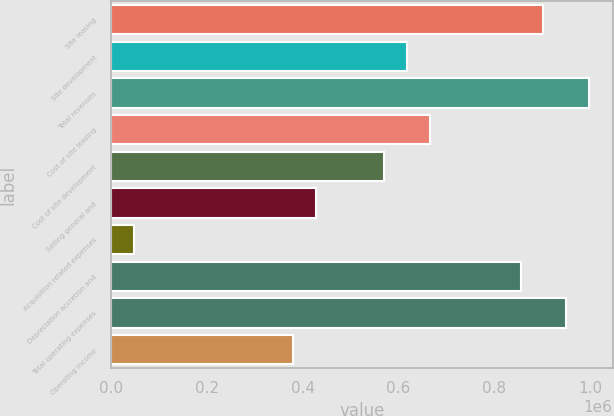Convert chart to OTSL. <chart><loc_0><loc_0><loc_500><loc_500><bar_chart><fcel>Site leasing<fcel>Site development<fcel>Total revenues<fcel>Cost of site leasing<fcel>Cost of site development<fcel>Selling general and<fcel>Acquisition related expenses<fcel>Depreciation accretion and<fcel>Total operating expenses<fcel>Operating income<nl><fcel>902412<fcel>617440<fcel>997403<fcel>664935<fcel>569945<fcel>427459<fcel>47495.9<fcel>854917<fcel>949907<fcel>379963<nl></chart> 